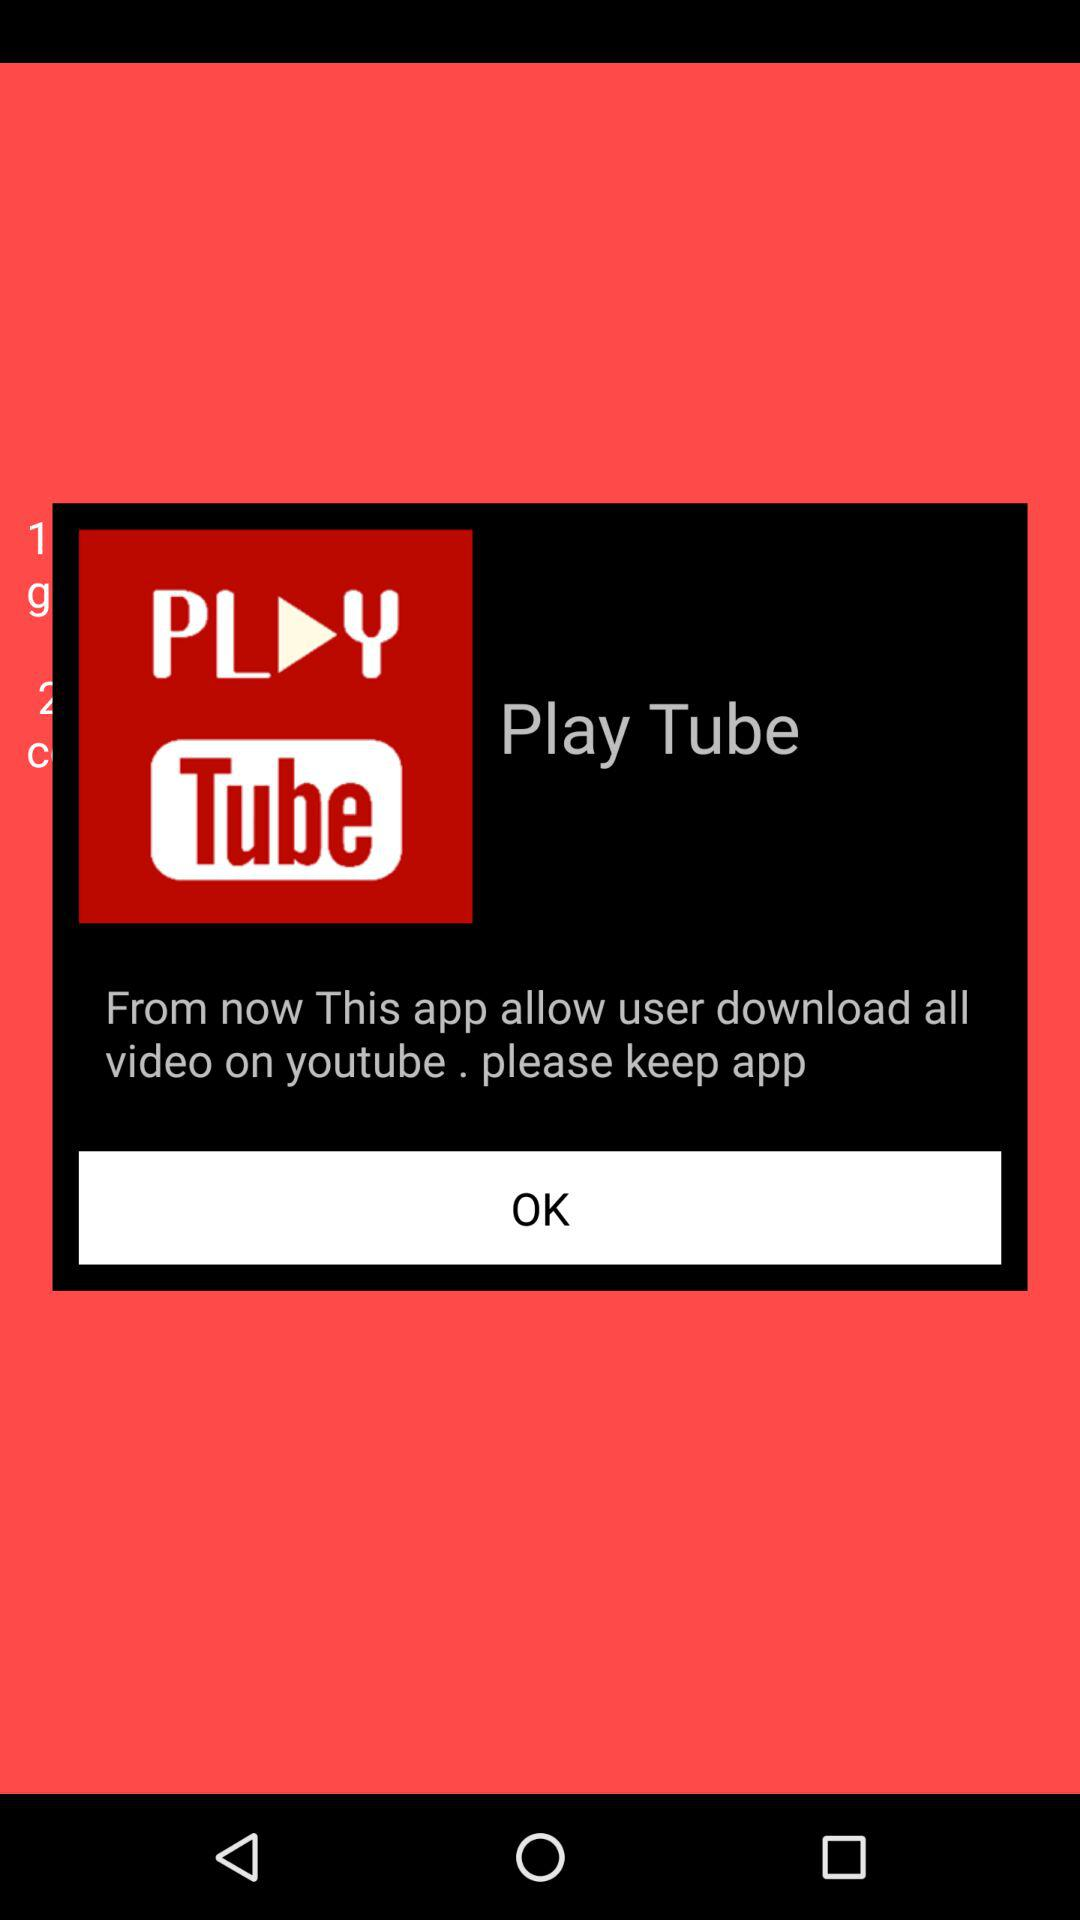What is the application name? The application name is "Play Tube". 